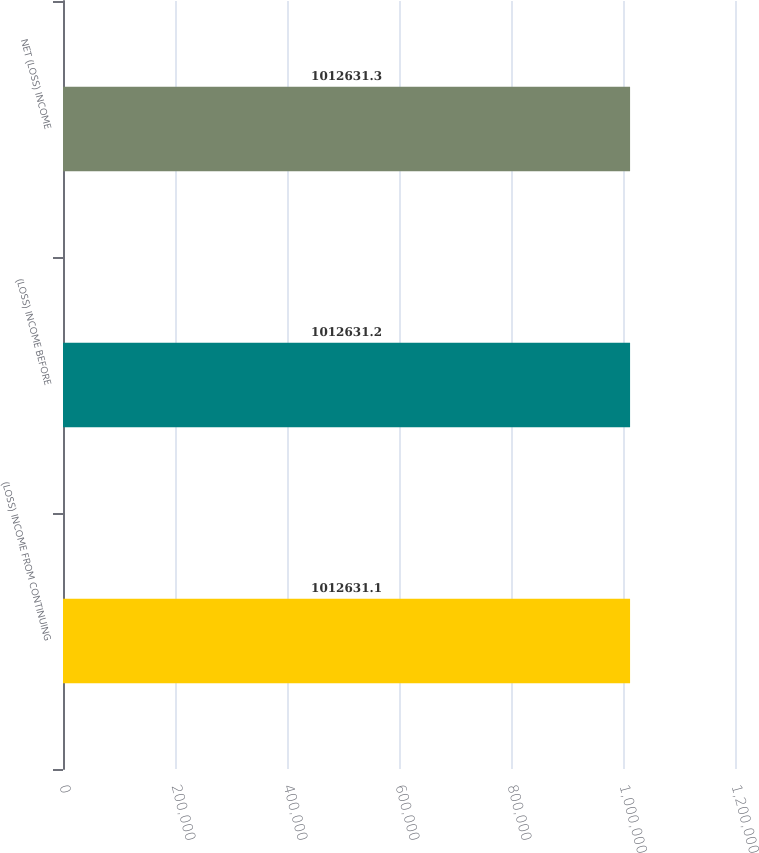<chart> <loc_0><loc_0><loc_500><loc_500><bar_chart><fcel>(LOSS) INCOME FROM CONTINUING<fcel>(LOSS) INCOME BEFORE<fcel>NET (LOSS) INCOME<nl><fcel>1.01263e+06<fcel>1.01263e+06<fcel>1.01263e+06<nl></chart> 